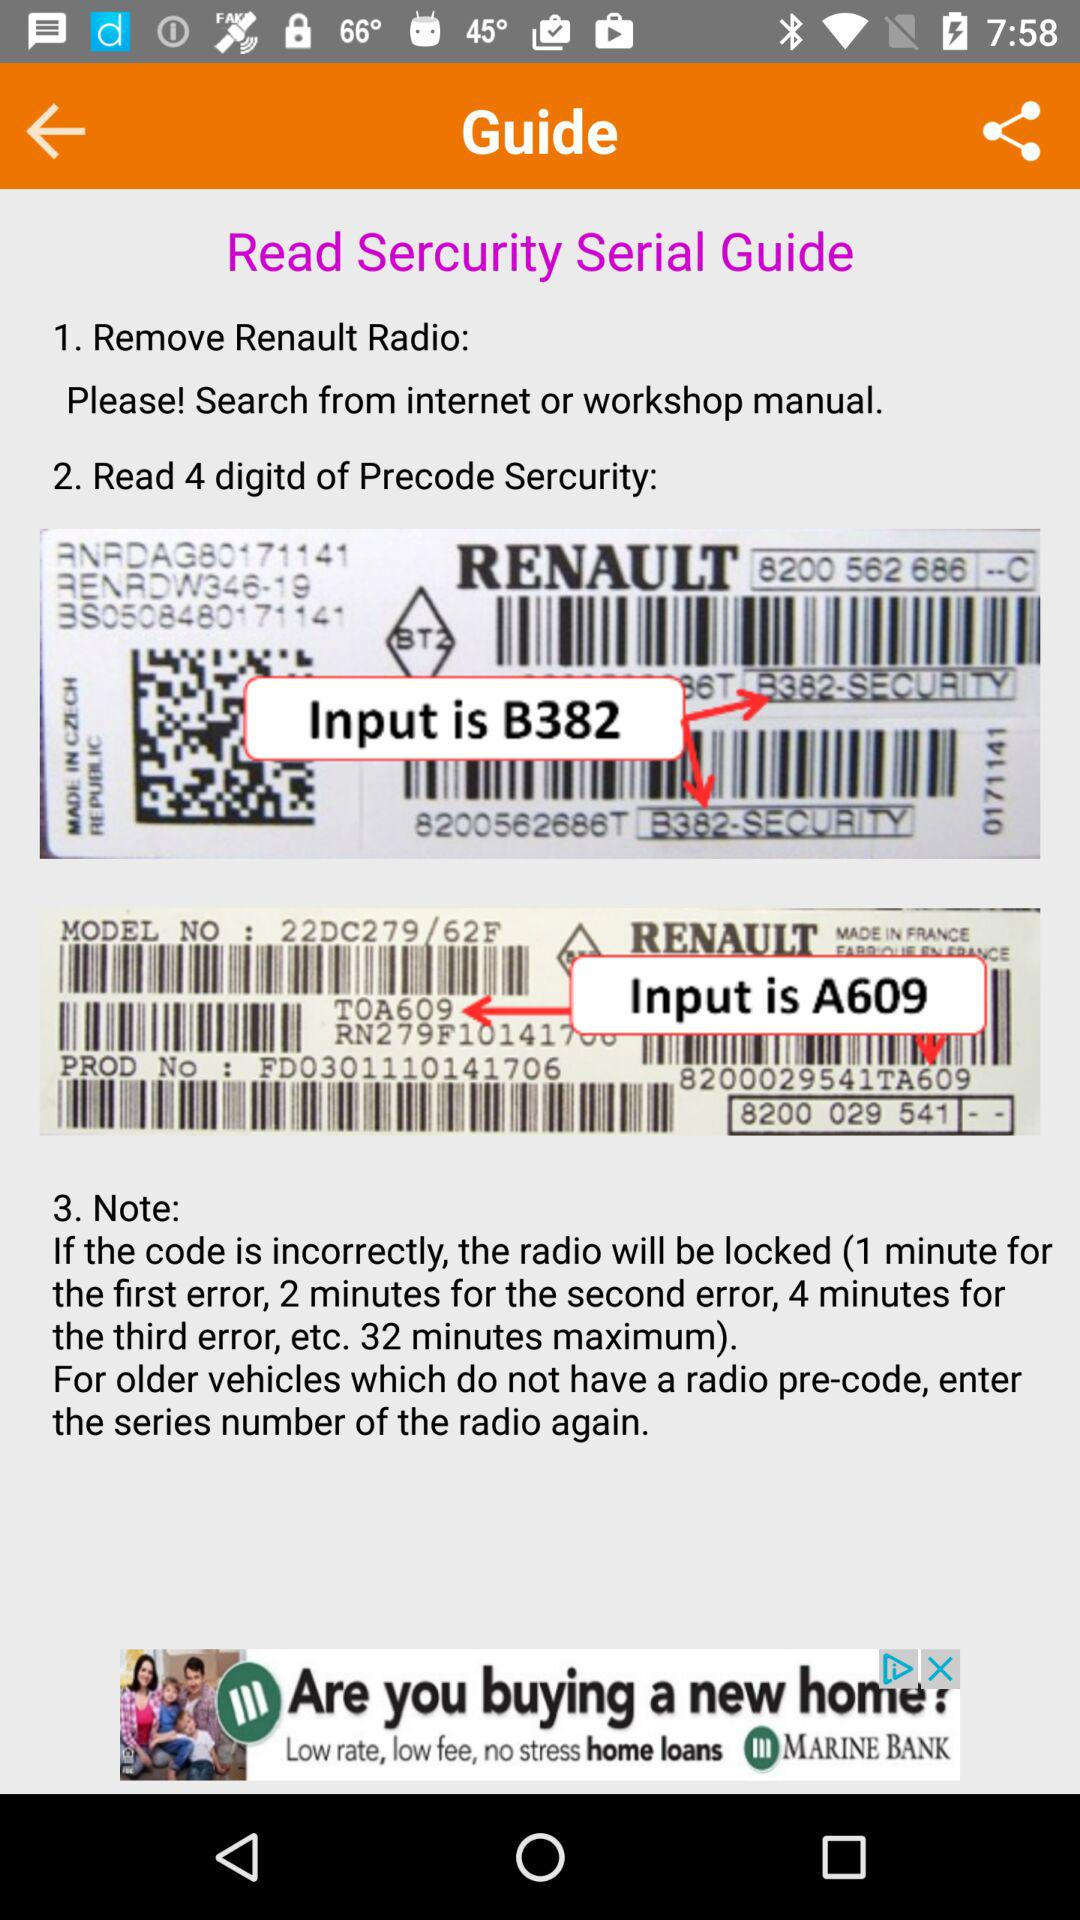What is the model number? The model number is "22DC279 / 62F". 